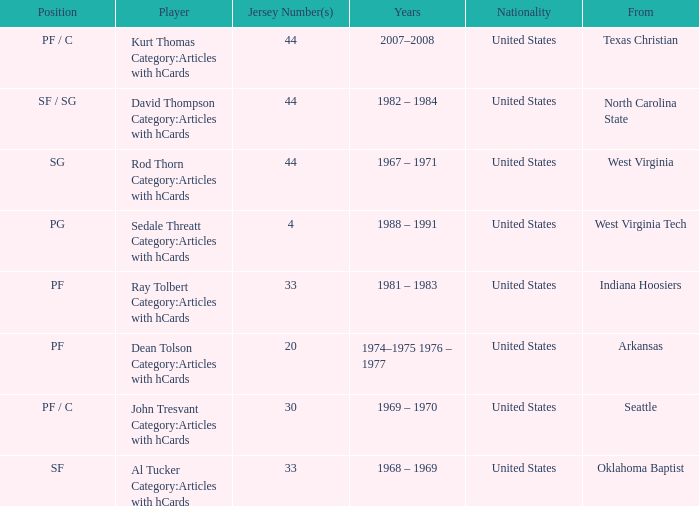What years did the player with the jersey number bigger than 20 play? 2007–2008, 1982 – 1984, 1967 – 1971, 1981 – 1983, 1969 – 1970, 1968 – 1969. 